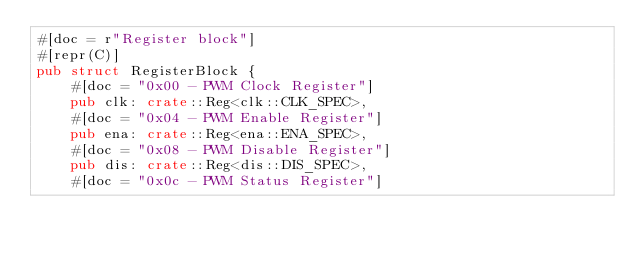Convert code to text. <code><loc_0><loc_0><loc_500><loc_500><_Rust_>#[doc = r"Register block"]
#[repr(C)]
pub struct RegisterBlock {
    #[doc = "0x00 - PWM Clock Register"]
    pub clk: crate::Reg<clk::CLK_SPEC>,
    #[doc = "0x04 - PWM Enable Register"]
    pub ena: crate::Reg<ena::ENA_SPEC>,
    #[doc = "0x08 - PWM Disable Register"]
    pub dis: crate::Reg<dis::DIS_SPEC>,
    #[doc = "0x0c - PWM Status Register"]</code> 